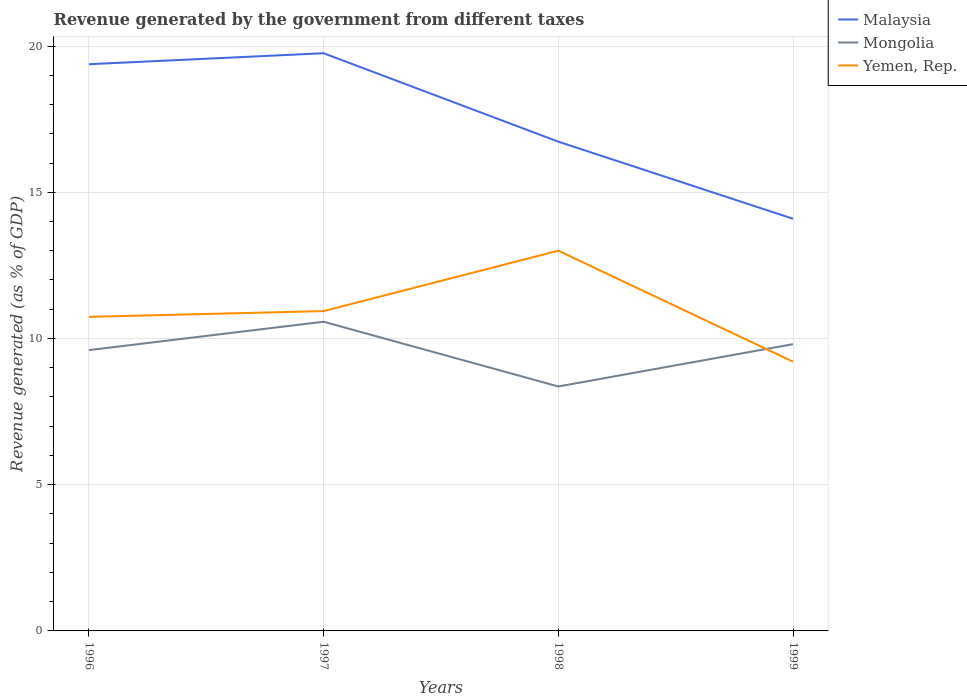Is the number of lines equal to the number of legend labels?
Your response must be concise. Yes. Across all years, what is the maximum revenue generated by the government in Mongolia?
Provide a short and direct response. 8.36. What is the total revenue generated by the government in Yemen, Rep. in the graph?
Make the answer very short. 1.53. What is the difference between the highest and the second highest revenue generated by the government in Malaysia?
Make the answer very short. 5.66. What is the difference between the highest and the lowest revenue generated by the government in Yemen, Rep.?
Your response must be concise. 1. What is the difference between two consecutive major ticks on the Y-axis?
Offer a very short reply. 5. Does the graph contain grids?
Ensure brevity in your answer.  Yes. Where does the legend appear in the graph?
Make the answer very short. Top right. How many legend labels are there?
Ensure brevity in your answer.  3. How are the legend labels stacked?
Ensure brevity in your answer.  Vertical. What is the title of the graph?
Provide a succinct answer. Revenue generated by the government from different taxes. Does "Kenya" appear as one of the legend labels in the graph?
Provide a short and direct response. No. What is the label or title of the X-axis?
Give a very brief answer. Years. What is the label or title of the Y-axis?
Your answer should be very brief. Revenue generated (as % of GDP). What is the Revenue generated (as % of GDP) of Malaysia in 1996?
Provide a succinct answer. 19.38. What is the Revenue generated (as % of GDP) in Mongolia in 1996?
Your answer should be compact. 9.6. What is the Revenue generated (as % of GDP) of Yemen, Rep. in 1996?
Ensure brevity in your answer.  10.74. What is the Revenue generated (as % of GDP) of Malaysia in 1997?
Ensure brevity in your answer.  19.75. What is the Revenue generated (as % of GDP) in Mongolia in 1997?
Provide a short and direct response. 10.57. What is the Revenue generated (as % of GDP) of Yemen, Rep. in 1997?
Offer a terse response. 10.94. What is the Revenue generated (as % of GDP) of Malaysia in 1998?
Provide a succinct answer. 16.73. What is the Revenue generated (as % of GDP) of Mongolia in 1998?
Your response must be concise. 8.36. What is the Revenue generated (as % of GDP) of Yemen, Rep. in 1998?
Keep it short and to the point. 13. What is the Revenue generated (as % of GDP) of Malaysia in 1999?
Your answer should be compact. 14.09. What is the Revenue generated (as % of GDP) in Mongolia in 1999?
Make the answer very short. 9.81. What is the Revenue generated (as % of GDP) of Yemen, Rep. in 1999?
Ensure brevity in your answer.  9.21. Across all years, what is the maximum Revenue generated (as % of GDP) of Malaysia?
Offer a very short reply. 19.75. Across all years, what is the maximum Revenue generated (as % of GDP) of Mongolia?
Your answer should be compact. 10.57. Across all years, what is the maximum Revenue generated (as % of GDP) in Yemen, Rep.?
Your answer should be very brief. 13. Across all years, what is the minimum Revenue generated (as % of GDP) of Malaysia?
Your response must be concise. 14.09. Across all years, what is the minimum Revenue generated (as % of GDP) of Mongolia?
Your answer should be compact. 8.36. Across all years, what is the minimum Revenue generated (as % of GDP) of Yemen, Rep.?
Give a very brief answer. 9.21. What is the total Revenue generated (as % of GDP) of Malaysia in the graph?
Provide a short and direct response. 69.96. What is the total Revenue generated (as % of GDP) of Mongolia in the graph?
Your answer should be compact. 38.34. What is the total Revenue generated (as % of GDP) in Yemen, Rep. in the graph?
Keep it short and to the point. 43.88. What is the difference between the Revenue generated (as % of GDP) in Malaysia in 1996 and that in 1997?
Provide a short and direct response. -0.38. What is the difference between the Revenue generated (as % of GDP) of Mongolia in 1996 and that in 1997?
Give a very brief answer. -0.97. What is the difference between the Revenue generated (as % of GDP) in Yemen, Rep. in 1996 and that in 1997?
Provide a short and direct response. -0.2. What is the difference between the Revenue generated (as % of GDP) in Malaysia in 1996 and that in 1998?
Your answer should be very brief. 2.65. What is the difference between the Revenue generated (as % of GDP) in Mongolia in 1996 and that in 1998?
Offer a terse response. 1.24. What is the difference between the Revenue generated (as % of GDP) in Yemen, Rep. in 1996 and that in 1998?
Offer a terse response. -2.26. What is the difference between the Revenue generated (as % of GDP) in Malaysia in 1996 and that in 1999?
Your answer should be compact. 5.28. What is the difference between the Revenue generated (as % of GDP) in Mongolia in 1996 and that in 1999?
Make the answer very short. -0.2. What is the difference between the Revenue generated (as % of GDP) in Yemen, Rep. in 1996 and that in 1999?
Your answer should be very brief. 1.53. What is the difference between the Revenue generated (as % of GDP) in Malaysia in 1997 and that in 1998?
Give a very brief answer. 3.02. What is the difference between the Revenue generated (as % of GDP) of Mongolia in 1997 and that in 1998?
Offer a very short reply. 2.21. What is the difference between the Revenue generated (as % of GDP) in Yemen, Rep. in 1997 and that in 1998?
Keep it short and to the point. -2.06. What is the difference between the Revenue generated (as % of GDP) of Malaysia in 1997 and that in 1999?
Provide a succinct answer. 5.66. What is the difference between the Revenue generated (as % of GDP) of Mongolia in 1997 and that in 1999?
Your answer should be very brief. 0.77. What is the difference between the Revenue generated (as % of GDP) of Yemen, Rep. in 1997 and that in 1999?
Provide a succinct answer. 1.73. What is the difference between the Revenue generated (as % of GDP) of Malaysia in 1998 and that in 1999?
Give a very brief answer. 2.64. What is the difference between the Revenue generated (as % of GDP) in Mongolia in 1998 and that in 1999?
Make the answer very short. -1.45. What is the difference between the Revenue generated (as % of GDP) of Yemen, Rep. in 1998 and that in 1999?
Offer a very short reply. 3.79. What is the difference between the Revenue generated (as % of GDP) of Malaysia in 1996 and the Revenue generated (as % of GDP) of Mongolia in 1997?
Make the answer very short. 8.81. What is the difference between the Revenue generated (as % of GDP) of Malaysia in 1996 and the Revenue generated (as % of GDP) of Yemen, Rep. in 1997?
Keep it short and to the point. 8.44. What is the difference between the Revenue generated (as % of GDP) in Mongolia in 1996 and the Revenue generated (as % of GDP) in Yemen, Rep. in 1997?
Your response must be concise. -1.33. What is the difference between the Revenue generated (as % of GDP) in Malaysia in 1996 and the Revenue generated (as % of GDP) in Mongolia in 1998?
Your answer should be compact. 11.02. What is the difference between the Revenue generated (as % of GDP) in Malaysia in 1996 and the Revenue generated (as % of GDP) in Yemen, Rep. in 1998?
Offer a terse response. 6.38. What is the difference between the Revenue generated (as % of GDP) in Mongolia in 1996 and the Revenue generated (as % of GDP) in Yemen, Rep. in 1998?
Your answer should be compact. -3.4. What is the difference between the Revenue generated (as % of GDP) in Malaysia in 1996 and the Revenue generated (as % of GDP) in Mongolia in 1999?
Ensure brevity in your answer.  9.57. What is the difference between the Revenue generated (as % of GDP) in Malaysia in 1996 and the Revenue generated (as % of GDP) in Yemen, Rep. in 1999?
Provide a succinct answer. 10.17. What is the difference between the Revenue generated (as % of GDP) of Mongolia in 1996 and the Revenue generated (as % of GDP) of Yemen, Rep. in 1999?
Make the answer very short. 0.4. What is the difference between the Revenue generated (as % of GDP) of Malaysia in 1997 and the Revenue generated (as % of GDP) of Mongolia in 1998?
Your answer should be very brief. 11.39. What is the difference between the Revenue generated (as % of GDP) of Malaysia in 1997 and the Revenue generated (as % of GDP) of Yemen, Rep. in 1998?
Your answer should be compact. 6.75. What is the difference between the Revenue generated (as % of GDP) of Mongolia in 1997 and the Revenue generated (as % of GDP) of Yemen, Rep. in 1998?
Keep it short and to the point. -2.43. What is the difference between the Revenue generated (as % of GDP) in Malaysia in 1997 and the Revenue generated (as % of GDP) in Mongolia in 1999?
Your answer should be compact. 9.95. What is the difference between the Revenue generated (as % of GDP) in Malaysia in 1997 and the Revenue generated (as % of GDP) in Yemen, Rep. in 1999?
Keep it short and to the point. 10.55. What is the difference between the Revenue generated (as % of GDP) in Mongolia in 1997 and the Revenue generated (as % of GDP) in Yemen, Rep. in 1999?
Ensure brevity in your answer.  1.37. What is the difference between the Revenue generated (as % of GDP) in Malaysia in 1998 and the Revenue generated (as % of GDP) in Mongolia in 1999?
Ensure brevity in your answer.  6.92. What is the difference between the Revenue generated (as % of GDP) in Malaysia in 1998 and the Revenue generated (as % of GDP) in Yemen, Rep. in 1999?
Your response must be concise. 7.52. What is the difference between the Revenue generated (as % of GDP) of Mongolia in 1998 and the Revenue generated (as % of GDP) of Yemen, Rep. in 1999?
Provide a succinct answer. -0.85. What is the average Revenue generated (as % of GDP) in Malaysia per year?
Give a very brief answer. 17.49. What is the average Revenue generated (as % of GDP) in Mongolia per year?
Provide a succinct answer. 9.58. What is the average Revenue generated (as % of GDP) of Yemen, Rep. per year?
Make the answer very short. 10.97. In the year 1996, what is the difference between the Revenue generated (as % of GDP) in Malaysia and Revenue generated (as % of GDP) in Mongolia?
Provide a succinct answer. 9.78. In the year 1996, what is the difference between the Revenue generated (as % of GDP) of Malaysia and Revenue generated (as % of GDP) of Yemen, Rep.?
Make the answer very short. 8.64. In the year 1996, what is the difference between the Revenue generated (as % of GDP) in Mongolia and Revenue generated (as % of GDP) in Yemen, Rep.?
Offer a terse response. -1.14. In the year 1997, what is the difference between the Revenue generated (as % of GDP) of Malaysia and Revenue generated (as % of GDP) of Mongolia?
Ensure brevity in your answer.  9.18. In the year 1997, what is the difference between the Revenue generated (as % of GDP) in Malaysia and Revenue generated (as % of GDP) in Yemen, Rep.?
Make the answer very short. 8.82. In the year 1997, what is the difference between the Revenue generated (as % of GDP) in Mongolia and Revenue generated (as % of GDP) in Yemen, Rep.?
Keep it short and to the point. -0.36. In the year 1998, what is the difference between the Revenue generated (as % of GDP) of Malaysia and Revenue generated (as % of GDP) of Mongolia?
Offer a terse response. 8.37. In the year 1998, what is the difference between the Revenue generated (as % of GDP) of Malaysia and Revenue generated (as % of GDP) of Yemen, Rep.?
Your answer should be very brief. 3.73. In the year 1998, what is the difference between the Revenue generated (as % of GDP) of Mongolia and Revenue generated (as % of GDP) of Yemen, Rep.?
Your answer should be compact. -4.64. In the year 1999, what is the difference between the Revenue generated (as % of GDP) of Malaysia and Revenue generated (as % of GDP) of Mongolia?
Provide a succinct answer. 4.29. In the year 1999, what is the difference between the Revenue generated (as % of GDP) in Malaysia and Revenue generated (as % of GDP) in Yemen, Rep.?
Provide a succinct answer. 4.89. In the year 1999, what is the difference between the Revenue generated (as % of GDP) of Mongolia and Revenue generated (as % of GDP) of Yemen, Rep.?
Keep it short and to the point. 0.6. What is the ratio of the Revenue generated (as % of GDP) in Mongolia in 1996 to that in 1997?
Your response must be concise. 0.91. What is the ratio of the Revenue generated (as % of GDP) of Yemen, Rep. in 1996 to that in 1997?
Offer a very short reply. 0.98. What is the ratio of the Revenue generated (as % of GDP) of Malaysia in 1996 to that in 1998?
Your response must be concise. 1.16. What is the ratio of the Revenue generated (as % of GDP) of Mongolia in 1996 to that in 1998?
Provide a short and direct response. 1.15. What is the ratio of the Revenue generated (as % of GDP) in Yemen, Rep. in 1996 to that in 1998?
Keep it short and to the point. 0.83. What is the ratio of the Revenue generated (as % of GDP) of Malaysia in 1996 to that in 1999?
Your response must be concise. 1.37. What is the ratio of the Revenue generated (as % of GDP) in Mongolia in 1996 to that in 1999?
Your response must be concise. 0.98. What is the ratio of the Revenue generated (as % of GDP) in Yemen, Rep. in 1996 to that in 1999?
Provide a short and direct response. 1.17. What is the ratio of the Revenue generated (as % of GDP) of Malaysia in 1997 to that in 1998?
Offer a very short reply. 1.18. What is the ratio of the Revenue generated (as % of GDP) in Mongolia in 1997 to that in 1998?
Your answer should be compact. 1.26. What is the ratio of the Revenue generated (as % of GDP) in Yemen, Rep. in 1997 to that in 1998?
Offer a very short reply. 0.84. What is the ratio of the Revenue generated (as % of GDP) in Malaysia in 1997 to that in 1999?
Your answer should be compact. 1.4. What is the ratio of the Revenue generated (as % of GDP) of Mongolia in 1997 to that in 1999?
Your answer should be very brief. 1.08. What is the ratio of the Revenue generated (as % of GDP) of Yemen, Rep. in 1997 to that in 1999?
Provide a succinct answer. 1.19. What is the ratio of the Revenue generated (as % of GDP) of Malaysia in 1998 to that in 1999?
Your answer should be very brief. 1.19. What is the ratio of the Revenue generated (as % of GDP) in Mongolia in 1998 to that in 1999?
Keep it short and to the point. 0.85. What is the ratio of the Revenue generated (as % of GDP) in Yemen, Rep. in 1998 to that in 1999?
Your response must be concise. 1.41. What is the difference between the highest and the second highest Revenue generated (as % of GDP) of Malaysia?
Offer a very short reply. 0.38. What is the difference between the highest and the second highest Revenue generated (as % of GDP) in Mongolia?
Provide a succinct answer. 0.77. What is the difference between the highest and the second highest Revenue generated (as % of GDP) in Yemen, Rep.?
Provide a succinct answer. 2.06. What is the difference between the highest and the lowest Revenue generated (as % of GDP) of Malaysia?
Provide a succinct answer. 5.66. What is the difference between the highest and the lowest Revenue generated (as % of GDP) of Mongolia?
Make the answer very short. 2.21. What is the difference between the highest and the lowest Revenue generated (as % of GDP) of Yemen, Rep.?
Ensure brevity in your answer.  3.79. 